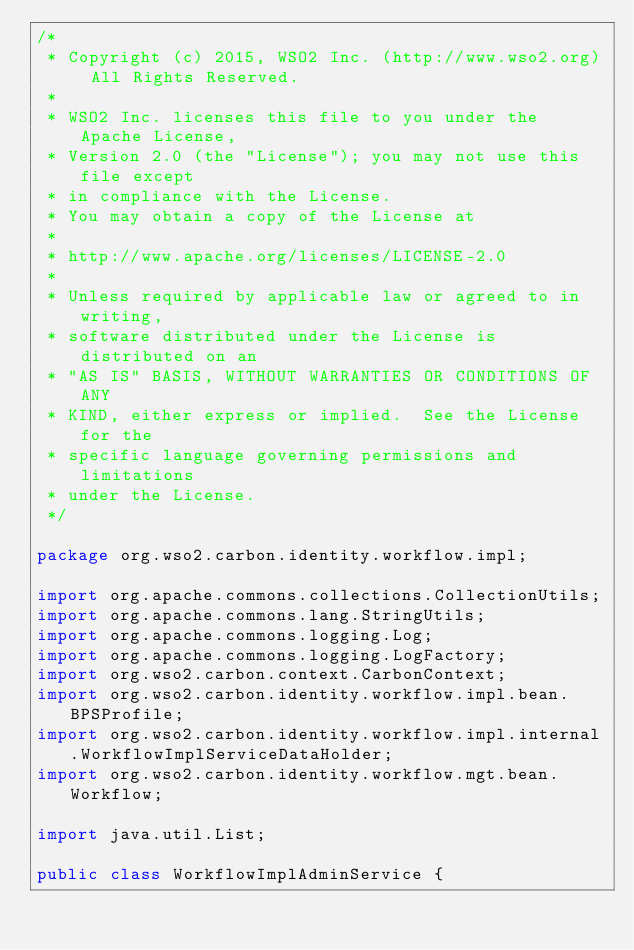<code> <loc_0><loc_0><loc_500><loc_500><_Java_>/*
 * Copyright (c) 2015, WSO2 Inc. (http://www.wso2.org) All Rights Reserved.
 *
 * WSO2 Inc. licenses this file to you under the Apache License,
 * Version 2.0 (the "License"); you may not use this file except
 * in compliance with the License.
 * You may obtain a copy of the License at
 *
 * http://www.apache.org/licenses/LICENSE-2.0
 *
 * Unless required by applicable law or agreed to in writing,
 * software distributed under the License is distributed on an
 * "AS IS" BASIS, WITHOUT WARRANTIES OR CONDITIONS OF ANY
 * KIND, either express or implied.  See the License for the
 * specific language governing permissions and limitations
 * under the License.
 */

package org.wso2.carbon.identity.workflow.impl;

import org.apache.commons.collections.CollectionUtils;
import org.apache.commons.lang.StringUtils;
import org.apache.commons.logging.Log;
import org.apache.commons.logging.LogFactory;
import org.wso2.carbon.context.CarbonContext;
import org.wso2.carbon.identity.workflow.impl.bean.BPSProfile;
import org.wso2.carbon.identity.workflow.impl.internal.WorkflowImplServiceDataHolder;
import org.wso2.carbon.identity.workflow.mgt.bean.Workflow;

import java.util.List;

public class WorkflowImplAdminService {
</code> 